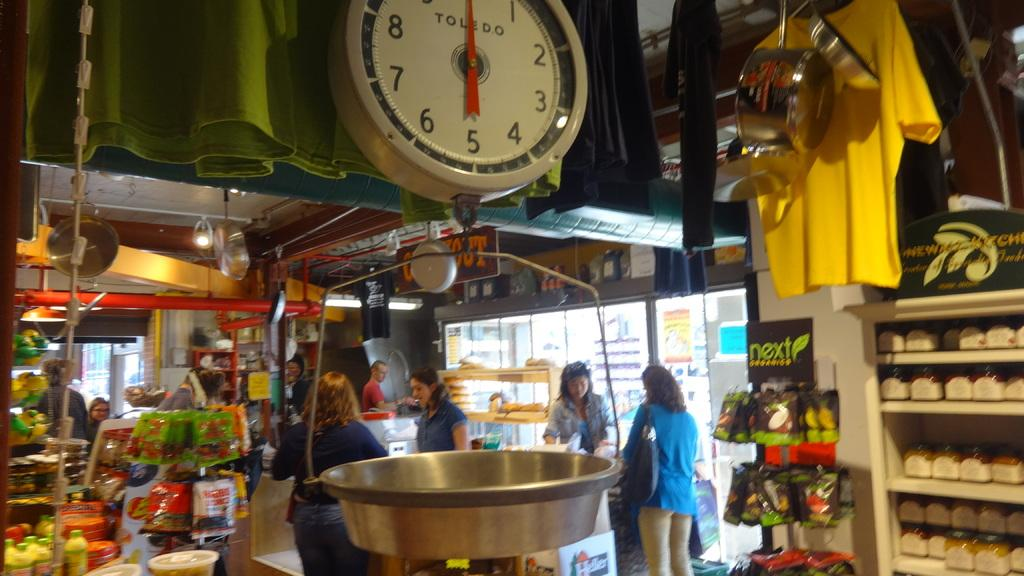<image>
Summarize the visual content of the image. A Toledo scale hangs in the foreground of a busy market. 